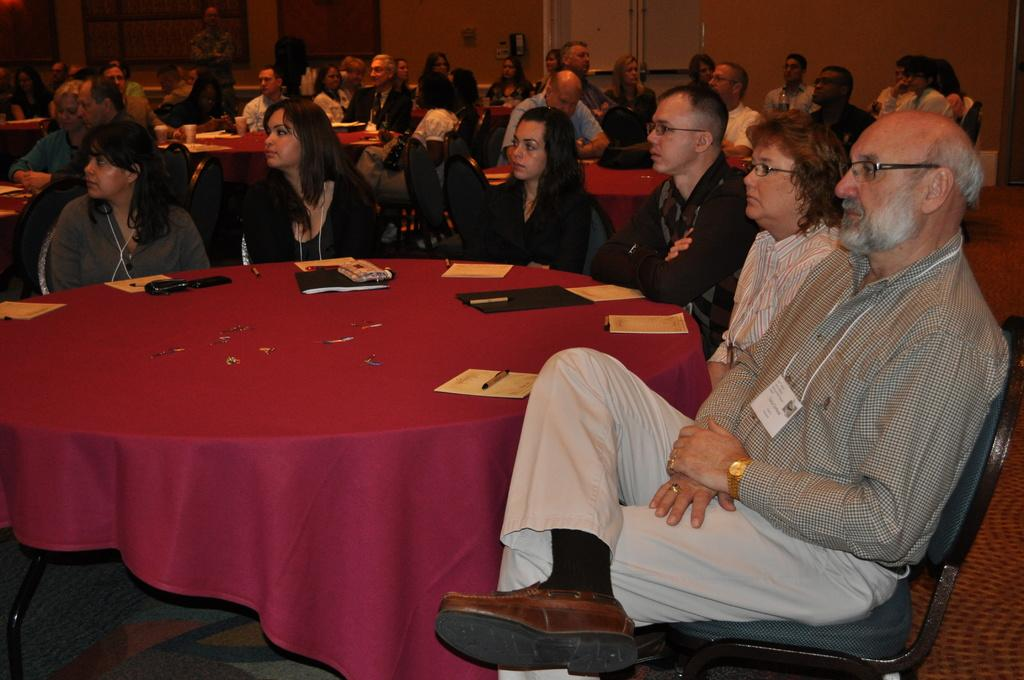What are the people in the image doing? The people in the image are sitting on chairs in a room. What is surrounding the chairs? The chairs are surrounded by tables. What is on one of the tables? There is a red cloth on one of the tables. What items can be seen on the red cloth? Papers and pens are present on the red cloth. Can you see a nest on any of the chairs in the image? There is no nest present on any of the chairs in the image. 